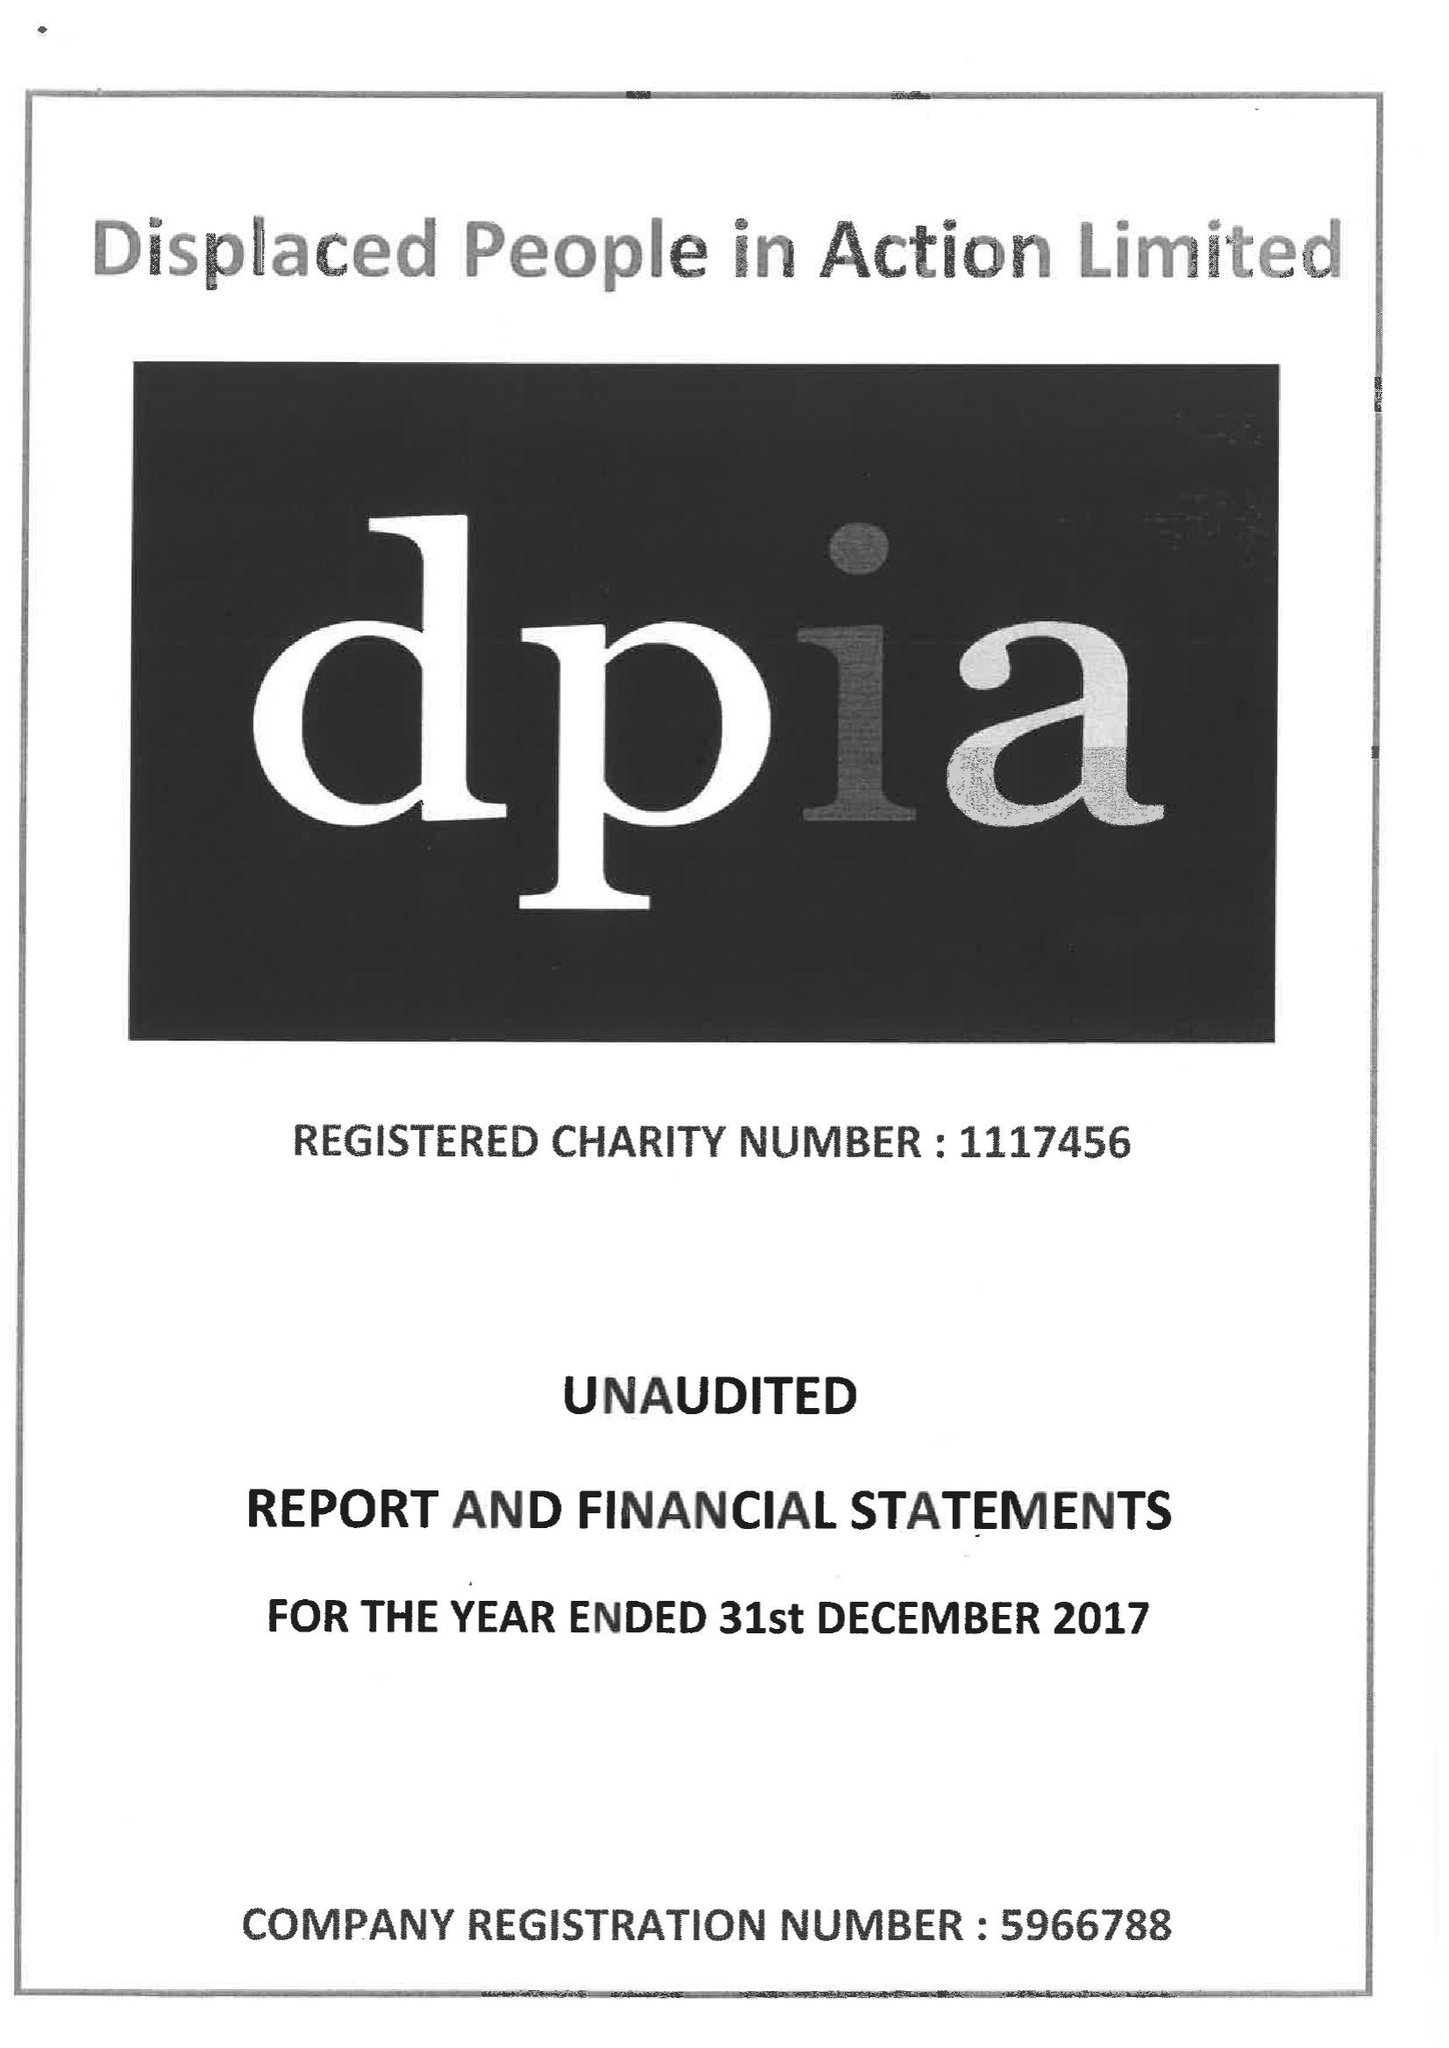What is the value for the charity_number?
Answer the question using a single word or phrase. 1117456 